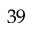Convert formula to latex. <formula><loc_0><loc_0><loc_500><loc_500>^ { 3 9 }</formula> 